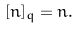<formula> <loc_0><loc_0><loc_500><loc_500>[ n ] _ { q } = n .</formula> 